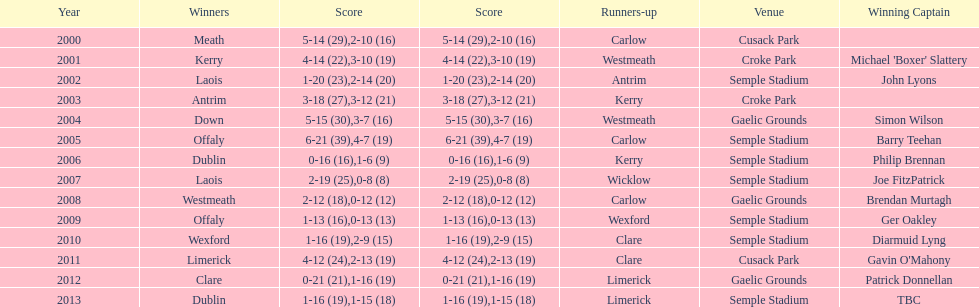In semple stadium, how many individuals emerged victorious? 7. 